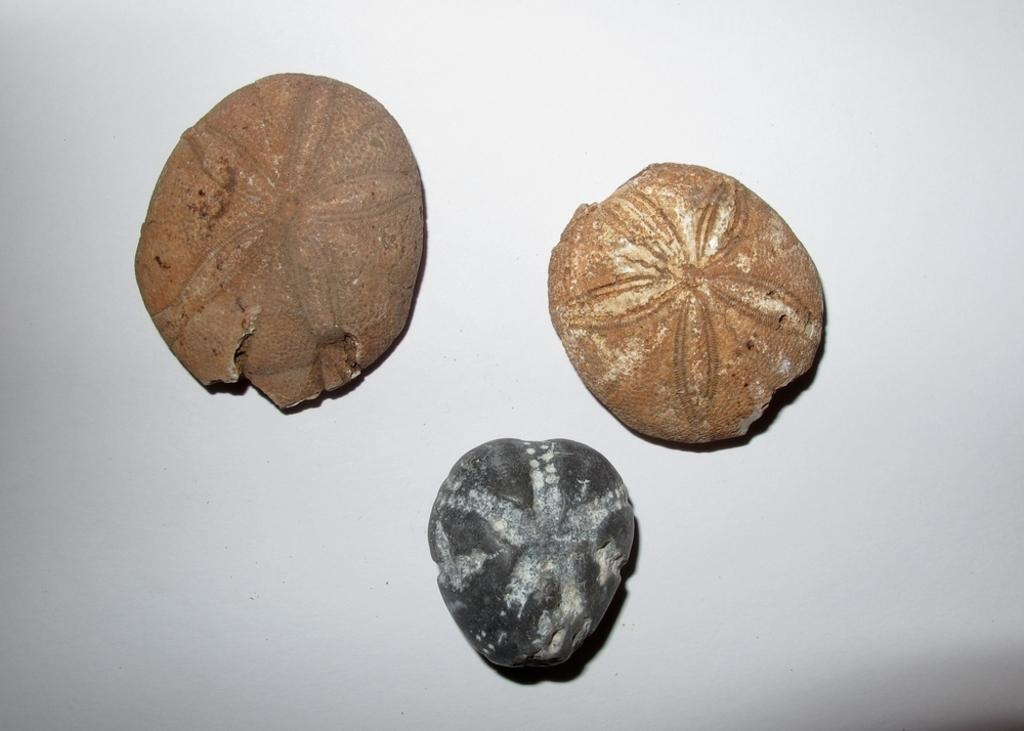What type of objects can be seen in the image? There are stones in the image. What is unique about the stones? The stones have carvings on them. On what surface are the stones placed? The stones are placed on a white surface. What type of playground equipment can be seen in the image? There is no playground equipment present in the image; it features stones with carvings on a white surface. How does the sail appear in the image? There is no sail present in the image. 